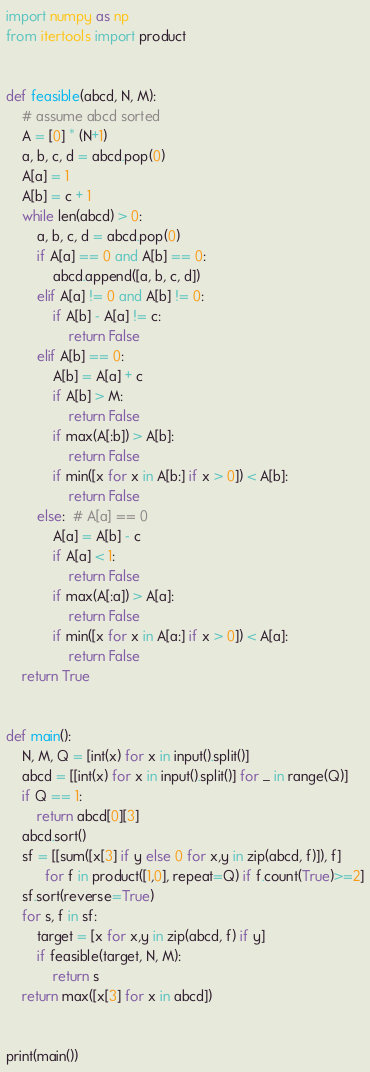<code> <loc_0><loc_0><loc_500><loc_500><_Python_>import numpy as np
from itertools import product


def feasible(abcd, N, M):
    # assume abcd sorted
    A = [0] * (N+1)
    a, b, c, d = abcd.pop(0)
    A[a] = 1
    A[b] = c + 1
    while len(abcd) > 0:
        a, b, c, d = abcd.pop(0)
        if A[a] == 0 and A[b] == 0:
            abcd.append([a, b, c, d])
        elif A[a] != 0 and A[b] != 0:
            if A[b] - A[a] != c:
                return False
        elif A[b] == 0:
            A[b] = A[a] + c
            if A[b] > M:
                return False
            if max(A[:b]) > A[b]:
                return False
            if min([x for x in A[b:] if x > 0]) < A[b]:
                return False
        else:  # A[a] == 0
            A[a] = A[b] - c
            if A[a] < 1:
                return False
            if max(A[:a]) > A[a]:
                return False
            if min([x for x in A[a:] if x > 0]) < A[a]:
                return False
    return True


def main():
    N, M, Q = [int(x) for x in input().split()]
    abcd = [[int(x) for x in input().split()] for _ in range(Q)]
    if Q == 1:
        return abcd[0][3]
    abcd.sort()
    sf = [[sum([x[3] if y else 0 for x,y in zip(abcd, f)]), f]
          for f in product([1,0], repeat=Q) if f.count(True)>=2]
    sf.sort(reverse=True)
    for s, f in sf:
        target = [x for x,y in zip(abcd, f) if y]
        if feasible(target, N, M):
            return s
    return max([x[3] for x in abcd])


print(main())
</code> 